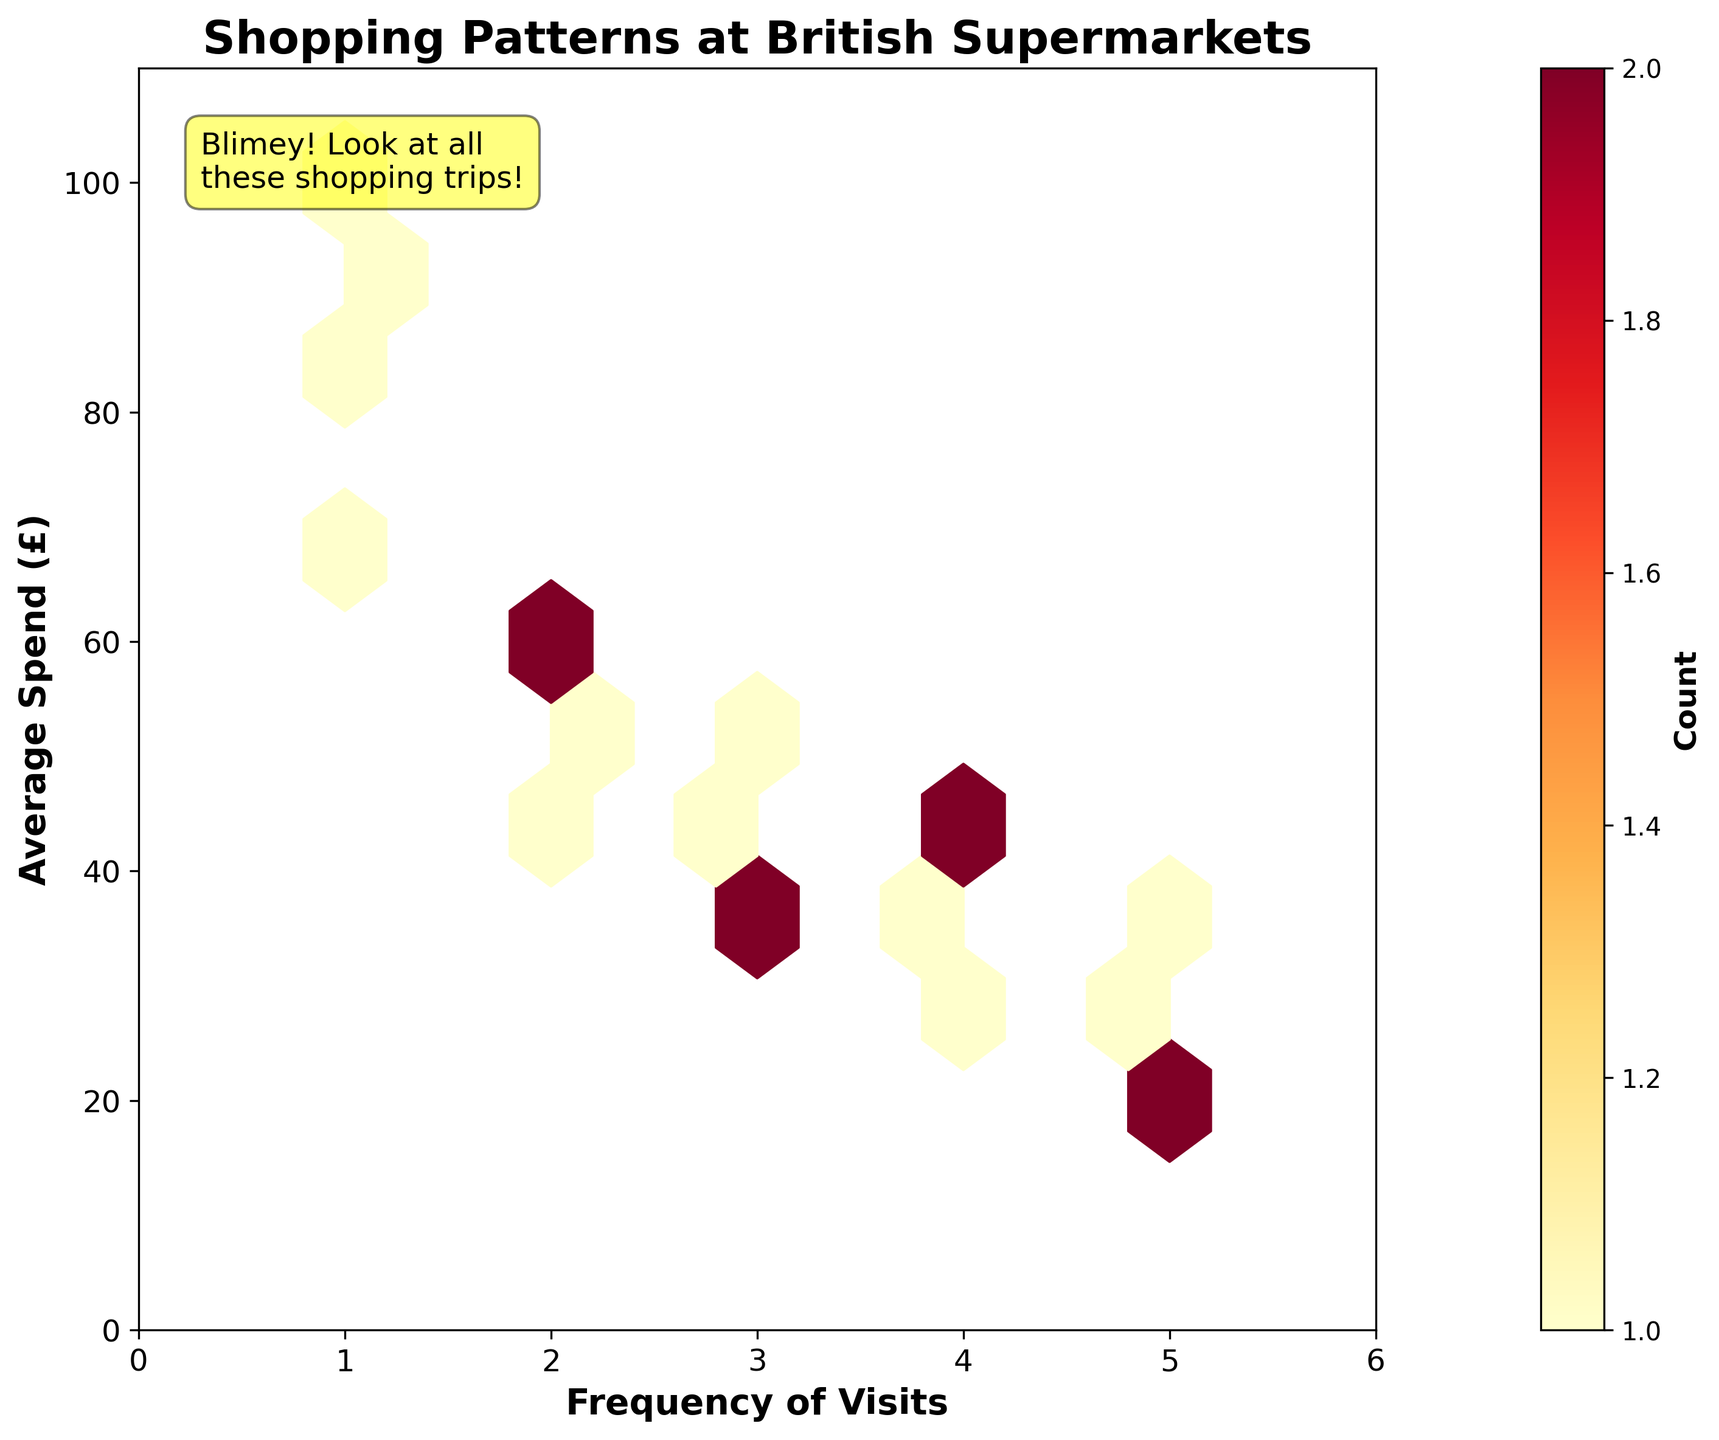What is the title of the plot? The title of the plot is typically placed at the top and is written in a larger and bold font. Here, the title is present as "Shopping Patterns at British Supermarkets."
Answer: Shopping Patterns at British Supermarkets What does the x-axis represent? The axis labels indicate what each axis represents. The label on the x-axis is "Frequency of Visits," indicating that it shows how often people visit supermarkets.
Answer: Frequency of Visits What does the y-axis represent? The y-axis label helps us understand what the vertical axis represents. Here, the label reads "Average Spend (£)," which means it shows the average amount of money spent during shopping trips.
Answer: Average Spend (£) What color palette is used in the hexbin plot? The color palette used in a plot generally helps in identifying different data densities. Here, "YlOrRd" is a sequential yellow-orange-red palette used to show counts.
Answer: Yellow-Orange-Red How many visits correspond to the highest spend in the dataset? To find this, we look for the highest y-axis value, which is £100. Corresponding x-axis value for this point is the frequency of 1 visit.
Answer: 1 Which frequency of visits is associated with the highest average spend? To answer this, observe the x-coordinate that corresponds to the maximum y-coordinate value. The highest average spend, £100, is associated with a frequency of 1 visit.
Answer: 1 visit What is the range of the x-axis and y-axis? Check the axis limits marked at the edges of the plot. The x-axis ranges from 0 to 6 and the y-axis ranges from 0 to 110.
Answer: x-axis: 0 to 6, y-axis: 0 to 110 What information is provided by the color bar? The color bar usually provides context about what the colors in the plot represent. In this plot, the color bar represents the count, which means how many data points fall within each hexagonal bin.
Answer: Count What is the count value where the frequency of visits is 2 and the average spend is around £50? To determine this, check the hexbin plot area where the x value is 2 and the y value is around 50. The color of this bin represents the count, generally detailed by the color scale. The shade should be identified by referencing the color bar.
Answer: 1 Which frequency of visits has the most clusters around average spend £40? Look for the densest concentration of hexagons around the y-value of £40. The most clusters should be evident at x-values (frequency of visits) of 3.
Answer: 3 visits 